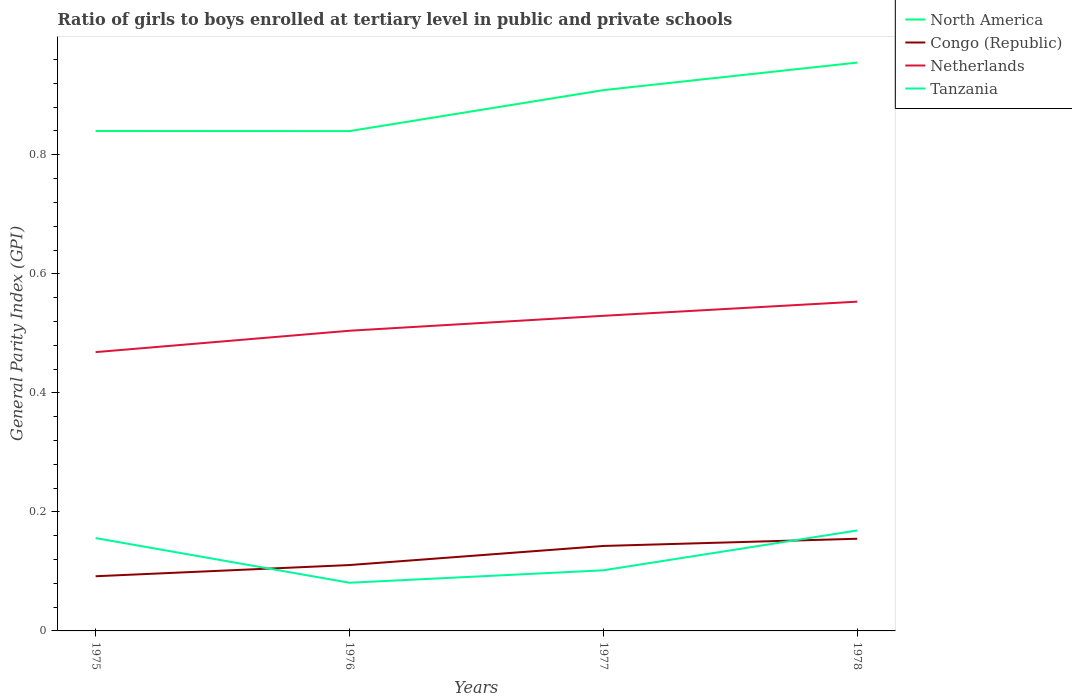Is the number of lines equal to the number of legend labels?
Ensure brevity in your answer.  Yes. Across all years, what is the maximum general parity index in Tanzania?
Your response must be concise. 0.08. In which year was the general parity index in Congo (Republic) maximum?
Offer a terse response. 1975. What is the total general parity index in North America in the graph?
Ensure brevity in your answer.  -0.11. What is the difference between the highest and the second highest general parity index in Tanzania?
Make the answer very short. 0.09. Is the general parity index in Tanzania strictly greater than the general parity index in Congo (Republic) over the years?
Give a very brief answer. No. Does the graph contain any zero values?
Provide a short and direct response. No. Does the graph contain grids?
Offer a terse response. No. Where does the legend appear in the graph?
Give a very brief answer. Top right. How many legend labels are there?
Give a very brief answer. 4. What is the title of the graph?
Provide a succinct answer. Ratio of girls to boys enrolled at tertiary level in public and private schools. What is the label or title of the X-axis?
Make the answer very short. Years. What is the label or title of the Y-axis?
Offer a terse response. General Parity Index (GPI). What is the General Parity Index (GPI) in North America in 1975?
Offer a very short reply. 0.84. What is the General Parity Index (GPI) of Congo (Republic) in 1975?
Keep it short and to the point. 0.09. What is the General Parity Index (GPI) of Netherlands in 1975?
Provide a short and direct response. 0.47. What is the General Parity Index (GPI) of Tanzania in 1975?
Ensure brevity in your answer.  0.16. What is the General Parity Index (GPI) in North America in 1976?
Your answer should be compact. 0.84. What is the General Parity Index (GPI) in Congo (Republic) in 1976?
Offer a very short reply. 0.11. What is the General Parity Index (GPI) in Netherlands in 1976?
Ensure brevity in your answer.  0.5. What is the General Parity Index (GPI) in Tanzania in 1976?
Make the answer very short. 0.08. What is the General Parity Index (GPI) in North America in 1977?
Provide a succinct answer. 0.91. What is the General Parity Index (GPI) of Congo (Republic) in 1977?
Offer a very short reply. 0.14. What is the General Parity Index (GPI) of Netherlands in 1977?
Your response must be concise. 0.53. What is the General Parity Index (GPI) in Tanzania in 1977?
Give a very brief answer. 0.1. What is the General Parity Index (GPI) in North America in 1978?
Offer a very short reply. 0.95. What is the General Parity Index (GPI) of Congo (Republic) in 1978?
Keep it short and to the point. 0.15. What is the General Parity Index (GPI) of Netherlands in 1978?
Give a very brief answer. 0.55. What is the General Parity Index (GPI) in Tanzania in 1978?
Give a very brief answer. 0.17. Across all years, what is the maximum General Parity Index (GPI) of North America?
Make the answer very short. 0.95. Across all years, what is the maximum General Parity Index (GPI) in Congo (Republic)?
Provide a succinct answer. 0.15. Across all years, what is the maximum General Parity Index (GPI) of Netherlands?
Your answer should be compact. 0.55. Across all years, what is the maximum General Parity Index (GPI) in Tanzania?
Make the answer very short. 0.17. Across all years, what is the minimum General Parity Index (GPI) of North America?
Provide a short and direct response. 0.84. Across all years, what is the minimum General Parity Index (GPI) in Congo (Republic)?
Ensure brevity in your answer.  0.09. Across all years, what is the minimum General Parity Index (GPI) of Netherlands?
Your answer should be very brief. 0.47. Across all years, what is the minimum General Parity Index (GPI) of Tanzania?
Provide a succinct answer. 0.08. What is the total General Parity Index (GPI) of North America in the graph?
Provide a short and direct response. 3.54. What is the total General Parity Index (GPI) of Congo (Republic) in the graph?
Provide a succinct answer. 0.5. What is the total General Parity Index (GPI) of Netherlands in the graph?
Your answer should be very brief. 2.06. What is the total General Parity Index (GPI) in Tanzania in the graph?
Ensure brevity in your answer.  0.51. What is the difference between the General Parity Index (GPI) in Congo (Republic) in 1975 and that in 1976?
Give a very brief answer. -0.02. What is the difference between the General Parity Index (GPI) in Netherlands in 1975 and that in 1976?
Provide a succinct answer. -0.04. What is the difference between the General Parity Index (GPI) of Tanzania in 1975 and that in 1976?
Offer a terse response. 0.07. What is the difference between the General Parity Index (GPI) of North America in 1975 and that in 1977?
Make the answer very short. -0.07. What is the difference between the General Parity Index (GPI) in Congo (Republic) in 1975 and that in 1977?
Your response must be concise. -0.05. What is the difference between the General Parity Index (GPI) in Netherlands in 1975 and that in 1977?
Your answer should be very brief. -0.06. What is the difference between the General Parity Index (GPI) in Tanzania in 1975 and that in 1977?
Provide a succinct answer. 0.05. What is the difference between the General Parity Index (GPI) of North America in 1975 and that in 1978?
Your response must be concise. -0.12. What is the difference between the General Parity Index (GPI) of Congo (Republic) in 1975 and that in 1978?
Provide a succinct answer. -0.06. What is the difference between the General Parity Index (GPI) in Netherlands in 1975 and that in 1978?
Keep it short and to the point. -0.08. What is the difference between the General Parity Index (GPI) of Tanzania in 1975 and that in 1978?
Your answer should be compact. -0.01. What is the difference between the General Parity Index (GPI) in North America in 1976 and that in 1977?
Make the answer very short. -0.07. What is the difference between the General Parity Index (GPI) of Congo (Republic) in 1976 and that in 1977?
Your answer should be very brief. -0.03. What is the difference between the General Parity Index (GPI) in Netherlands in 1976 and that in 1977?
Your answer should be very brief. -0.03. What is the difference between the General Parity Index (GPI) in Tanzania in 1976 and that in 1977?
Your answer should be compact. -0.02. What is the difference between the General Parity Index (GPI) in North America in 1976 and that in 1978?
Provide a short and direct response. -0.12. What is the difference between the General Parity Index (GPI) in Congo (Republic) in 1976 and that in 1978?
Your answer should be compact. -0.04. What is the difference between the General Parity Index (GPI) of Netherlands in 1976 and that in 1978?
Provide a succinct answer. -0.05. What is the difference between the General Parity Index (GPI) in Tanzania in 1976 and that in 1978?
Offer a very short reply. -0.09. What is the difference between the General Parity Index (GPI) in North America in 1977 and that in 1978?
Give a very brief answer. -0.05. What is the difference between the General Parity Index (GPI) of Congo (Republic) in 1977 and that in 1978?
Provide a short and direct response. -0.01. What is the difference between the General Parity Index (GPI) in Netherlands in 1977 and that in 1978?
Make the answer very short. -0.02. What is the difference between the General Parity Index (GPI) in Tanzania in 1977 and that in 1978?
Keep it short and to the point. -0.07. What is the difference between the General Parity Index (GPI) in North America in 1975 and the General Parity Index (GPI) in Congo (Republic) in 1976?
Give a very brief answer. 0.73. What is the difference between the General Parity Index (GPI) of North America in 1975 and the General Parity Index (GPI) of Netherlands in 1976?
Keep it short and to the point. 0.34. What is the difference between the General Parity Index (GPI) in North America in 1975 and the General Parity Index (GPI) in Tanzania in 1976?
Offer a terse response. 0.76. What is the difference between the General Parity Index (GPI) in Congo (Republic) in 1975 and the General Parity Index (GPI) in Netherlands in 1976?
Keep it short and to the point. -0.41. What is the difference between the General Parity Index (GPI) in Congo (Republic) in 1975 and the General Parity Index (GPI) in Tanzania in 1976?
Your answer should be very brief. 0.01. What is the difference between the General Parity Index (GPI) of Netherlands in 1975 and the General Parity Index (GPI) of Tanzania in 1976?
Your answer should be compact. 0.39. What is the difference between the General Parity Index (GPI) in North America in 1975 and the General Parity Index (GPI) in Congo (Republic) in 1977?
Keep it short and to the point. 0.7. What is the difference between the General Parity Index (GPI) in North America in 1975 and the General Parity Index (GPI) in Netherlands in 1977?
Offer a terse response. 0.31. What is the difference between the General Parity Index (GPI) in North America in 1975 and the General Parity Index (GPI) in Tanzania in 1977?
Make the answer very short. 0.74. What is the difference between the General Parity Index (GPI) of Congo (Republic) in 1975 and the General Parity Index (GPI) of Netherlands in 1977?
Make the answer very short. -0.44. What is the difference between the General Parity Index (GPI) of Congo (Republic) in 1975 and the General Parity Index (GPI) of Tanzania in 1977?
Offer a very short reply. -0.01. What is the difference between the General Parity Index (GPI) of Netherlands in 1975 and the General Parity Index (GPI) of Tanzania in 1977?
Provide a short and direct response. 0.37. What is the difference between the General Parity Index (GPI) in North America in 1975 and the General Parity Index (GPI) in Congo (Republic) in 1978?
Offer a terse response. 0.69. What is the difference between the General Parity Index (GPI) of North America in 1975 and the General Parity Index (GPI) of Netherlands in 1978?
Your answer should be compact. 0.29. What is the difference between the General Parity Index (GPI) in North America in 1975 and the General Parity Index (GPI) in Tanzania in 1978?
Provide a succinct answer. 0.67. What is the difference between the General Parity Index (GPI) in Congo (Republic) in 1975 and the General Parity Index (GPI) in Netherlands in 1978?
Ensure brevity in your answer.  -0.46. What is the difference between the General Parity Index (GPI) of Congo (Republic) in 1975 and the General Parity Index (GPI) of Tanzania in 1978?
Your answer should be very brief. -0.08. What is the difference between the General Parity Index (GPI) in Netherlands in 1975 and the General Parity Index (GPI) in Tanzania in 1978?
Ensure brevity in your answer.  0.3. What is the difference between the General Parity Index (GPI) in North America in 1976 and the General Parity Index (GPI) in Congo (Republic) in 1977?
Keep it short and to the point. 0.7. What is the difference between the General Parity Index (GPI) of North America in 1976 and the General Parity Index (GPI) of Netherlands in 1977?
Give a very brief answer. 0.31. What is the difference between the General Parity Index (GPI) of North America in 1976 and the General Parity Index (GPI) of Tanzania in 1977?
Provide a succinct answer. 0.74. What is the difference between the General Parity Index (GPI) in Congo (Republic) in 1976 and the General Parity Index (GPI) in Netherlands in 1977?
Ensure brevity in your answer.  -0.42. What is the difference between the General Parity Index (GPI) in Congo (Republic) in 1976 and the General Parity Index (GPI) in Tanzania in 1977?
Offer a terse response. 0.01. What is the difference between the General Parity Index (GPI) of Netherlands in 1976 and the General Parity Index (GPI) of Tanzania in 1977?
Provide a short and direct response. 0.4. What is the difference between the General Parity Index (GPI) in North America in 1976 and the General Parity Index (GPI) in Congo (Republic) in 1978?
Your answer should be very brief. 0.68. What is the difference between the General Parity Index (GPI) of North America in 1976 and the General Parity Index (GPI) of Netherlands in 1978?
Your response must be concise. 0.29. What is the difference between the General Parity Index (GPI) in North America in 1976 and the General Parity Index (GPI) in Tanzania in 1978?
Your response must be concise. 0.67. What is the difference between the General Parity Index (GPI) in Congo (Republic) in 1976 and the General Parity Index (GPI) in Netherlands in 1978?
Give a very brief answer. -0.44. What is the difference between the General Parity Index (GPI) of Congo (Republic) in 1976 and the General Parity Index (GPI) of Tanzania in 1978?
Make the answer very short. -0.06. What is the difference between the General Parity Index (GPI) of Netherlands in 1976 and the General Parity Index (GPI) of Tanzania in 1978?
Ensure brevity in your answer.  0.34. What is the difference between the General Parity Index (GPI) of North America in 1977 and the General Parity Index (GPI) of Congo (Republic) in 1978?
Ensure brevity in your answer.  0.75. What is the difference between the General Parity Index (GPI) in North America in 1977 and the General Parity Index (GPI) in Netherlands in 1978?
Your response must be concise. 0.36. What is the difference between the General Parity Index (GPI) of North America in 1977 and the General Parity Index (GPI) of Tanzania in 1978?
Provide a short and direct response. 0.74. What is the difference between the General Parity Index (GPI) in Congo (Republic) in 1977 and the General Parity Index (GPI) in Netherlands in 1978?
Make the answer very short. -0.41. What is the difference between the General Parity Index (GPI) of Congo (Republic) in 1977 and the General Parity Index (GPI) of Tanzania in 1978?
Your answer should be very brief. -0.03. What is the difference between the General Parity Index (GPI) of Netherlands in 1977 and the General Parity Index (GPI) of Tanzania in 1978?
Provide a short and direct response. 0.36. What is the average General Parity Index (GPI) in North America per year?
Provide a short and direct response. 0.89. What is the average General Parity Index (GPI) in Netherlands per year?
Your answer should be very brief. 0.51. What is the average General Parity Index (GPI) in Tanzania per year?
Offer a very short reply. 0.13. In the year 1975, what is the difference between the General Parity Index (GPI) in North America and General Parity Index (GPI) in Congo (Republic)?
Give a very brief answer. 0.75. In the year 1975, what is the difference between the General Parity Index (GPI) of North America and General Parity Index (GPI) of Netherlands?
Provide a short and direct response. 0.37. In the year 1975, what is the difference between the General Parity Index (GPI) of North America and General Parity Index (GPI) of Tanzania?
Provide a short and direct response. 0.68. In the year 1975, what is the difference between the General Parity Index (GPI) of Congo (Republic) and General Parity Index (GPI) of Netherlands?
Your answer should be very brief. -0.38. In the year 1975, what is the difference between the General Parity Index (GPI) of Congo (Republic) and General Parity Index (GPI) of Tanzania?
Provide a short and direct response. -0.06. In the year 1975, what is the difference between the General Parity Index (GPI) of Netherlands and General Parity Index (GPI) of Tanzania?
Offer a terse response. 0.31. In the year 1976, what is the difference between the General Parity Index (GPI) of North America and General Parity Index (GPI) of Congo (Republic)?
Your response must be concise. 0.73. In the year 1976, what is the difference between the General Parity Index (GPI) of North America and General Parity Index (GPI) of Netherlands?
Ensure brevity in your answer.  0.34. In the year 1976, what is the difference between the General Parity Index (GPI) in North America and General Parity Index (GPI) in Tanzania?
Provide a short and direct response. 0.76. In the year 1976, what is the difference between the General Parity Index (GPI) in Congo (Republic) and General Parity Index (GPI) in Netherlands?
Give a very brief answer. -0.39. In the year 1976, what is the difference between the General Parity Index (GPI) in Congo (Republic) and General Parity Index (GPI) in Tanzania?
Keep it short and to the point. 0.03. In the year 1976, what is the difference between the General Parity Index (GPI) in Netherlands and General Parity Index (GPI) in Tanzania?
Your answer should be compact. 0.42. In the year 1977, what is the difference between the General Parity Index (GPI) of North America and General Parity Index (GPI) of Congo (Republic)?
Your response must be concise. 0.77. In the year 1977, what is the difference between the General Parity Index (GPI) in North America and General Parity Index (GPI) in Netherlands?
Offer a very short reply. 0.38. In the year 1977, what is the difference between the General Parity Index (GPI) of North America and General Parity Index (GPI) of Tanzania?
Your response must be concise. 0.81. In the year 1977, what is the difference between the General Parity Index (GPI) of Congo (Republic) and General Parity Index (GPI) of Netherlands?
Offer a very short reply. -0.39. In the year 1977, what is the difference between the General Parity Index (GPI) of Congo (Republic) and General Parity Index (GPI) of Tanzania?
Offer a terse response. 0.04. In the year 1977, what is the difference between the General Parity Index (GPI) of Netherlands and General Parity Index (GPI) of Tanzania?
Provide a short and direct response. 0.43. In the year 1978, what is the difference between the General Parity Index (GPI) of North America and General Parity Index (GPI) of Netherlands?
Keep it short and to the point. 0.4. In the year 1978, what is the difference between the General Parity Index (GPI) in North America and General Parity Index (GPI) in Tanzania?
Your response must be concise. 0.79. In the year 1978, what is the difference between the General Parity Index (GPI) in Congo (Republic) and General Parity Index (GPI) in Netherlands?
Offer a very short reply. -0.4. In the year 1978, what is the difference between the General Parity Index (GPI) in Congo (Republic) and General Parity Index (GPI) in Tanzania?
Offer a very short reply. -0.01. In the year 1978, what is the difference between the General Parity Index (GPI) of Netherlands and General Parity Index (GPI) of Tanzania?
Provide a succinct answer. 0.38. What is the ratio of the General Parity Index (GPI) of North America in 1975 to that in 1976?
Offer a very short reply. 1. What is the ratio of the General Parity Index (GPI) in Congo (Republic) in 1975 to that in 1976?
Your answer should be very brief. 0.83. What is the ratio of the General Parity Index (GPI) of Netherlands in 1975 to that in 1976?
Make the answer very short. 0.93. What is the ratio of the General Parity Index (GPI) in Tanzania in 1975 to that in 1976?
Your response must be concise. 1.93. What is the ratio of the General Parity Index (GPI) in North America in 1975 to that in 1977?
Your response must be concise. 0.92. What is the ratio of the General Parity Index (GPI) of Congo (Republic) in 1975 to that in 1977?
Ensure brevity in your answer.  0.64. What is the ratio of the General Parity Index (GPI) in Netherlands in 1975 to that in 1977?
Your answer should be compact. 0.88. What is the ratio of the General Parity Index (GPI) in Tanzania in 1975 to that in 1977?
Provide a succinct answer. 1.53. What is the ratio of the General Parity Index (GPI) of North America in 1975 to that in 1978?
Give a very brief answer. 0.88. What is the ratio of the General Parity Index (GPI) of Congo (Republic) in 1975 to that in 1978?
Provide a succinct answer. 0.59. What is the ratio of the General Parity Index (GPI) in Netherlands in 1975 to that in 1978?
Give a very brief answer. 0.85. What is the ratio of the General Parity Index (GPI) of Tanzania in 1975 to that in 1978?
Make the answer very short. 0.92. What is the ratio of the General Parity Index (GPI) of North America in 1976 to that in 1977?
Ensure brevity in your answer.  0.92. What is the ratio of the General Parity Index (GPI) of Congo (Republic) in 1976 to that in 1977?
Keep it short and to the point. 0.78. What is the ratio of the General Parity Index (GPI) in Netherlands in 1976 to that in 1977?
Offer a very short reply. 0.95. What is the ratio of the General Parity Index (GPI) in Tanzania in 1976 to that in 1977?
Provide a succinct answer. 0.79. What is the ratio of the General Parity Index (GPI) in North America in 1976 to that in 1978?
Ensure brevity in your answer.  0.88. What is the ratio of the General Parity Index (GPI) in Congo (Republic) in 1976 to that in 1978?
Offer a terse response. 0.71. What is the ratio of the General Parity Index (GPI) of Netherlands in 1976 to that in 1978?
Give a very brief answer. 0.91. What is the ratio of the General Parity Index (GPI) of Tanzania in 1976 to that in 1978?
Keep it short and to the point. 0.48. What is the ratio of the General Parity Index (GPI) of North America in 1977 to that in 1978?
Provide a short and direct response. 0.95. What is the ratio of the General Parity Index (GPI) in Congo (Republic) in 1977 to that in 1978?
Provide a succinct answer. 0.92. What is the ratio of the General Parity Index (GPI) in Netherlands in 1977 to that in 1978?
Make the answer very short. 0.96. What is the ratio of the General Parity Index (GPI) in Tanzania in 1977 to that in 1978?
Provide a short and direct response. 0.6. What is the difference between the highest and the second highest General Parity Index (GPI) in North America?
Your response must be concise. 0.05. What is the difference between the highest and the second highest General Parity Index (GPI) in Congo (Republic)?
Your answer should be compact. 0.01. What is the difference between the highest and the second highest General Parity Index (GPI) in Netherlands?
Your answer should be very brief. 0.02. What is the difference between the highest and the second highest General Parity Index (GPI) in Tanzania?
Make the answer very short. 0.01. What is the difference between the highest and the lowest General Parity Index (GPI) in North America?
Ensure brevity in your answer.  0.12. What is the difference between the highest and the lowest General Parity Index (GPI) in Congo (Republic)?
Your answer should be compact. 0.06. What is the difference between the highest and the lowest General Parity Index (GPI) of Netherlands?
Keep it short and to the point. 0.08. What is the difference between the highest and the lowest General Parity Index (GPI) of Tanzania?
Give a very brief answer. 0.09. 